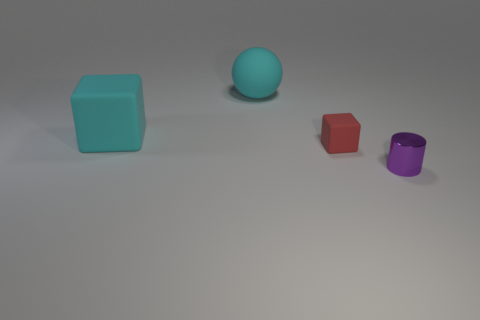What number of small objects are metallic cylinders or spheres?
Your answer should be compact. 1. What color is the large rubber thing that is the same shape as the small red object?
Your response must be concise. Cyan. Do the ball and the red object have the same size?
Provide a succinct answer. No. How many things are either small shiny objects or objects on the right side of the tiny rubber object?
Your response must be concise. 1. What is the color of the block that is behind the tiny thing to the left of the purple metallic cylinder?
Ensure brevity in your answer.  Cyan. Does the rubber thing that is in front of the large matte cube have the same color as the tiny cylinder?
Ensure brevity in your answer.  No. There is a tiny thing behind the purple metallic thing; what material is it?
Make the answer very short. Rubber. The metal object is what size?
Offer a very short reply. Small. Do the small thing left of the cylinder and the sphere have the same material?
Provide a short and direct response. Yes. What number of small red rubber things are there?
Keep it short and to the point. 1. 